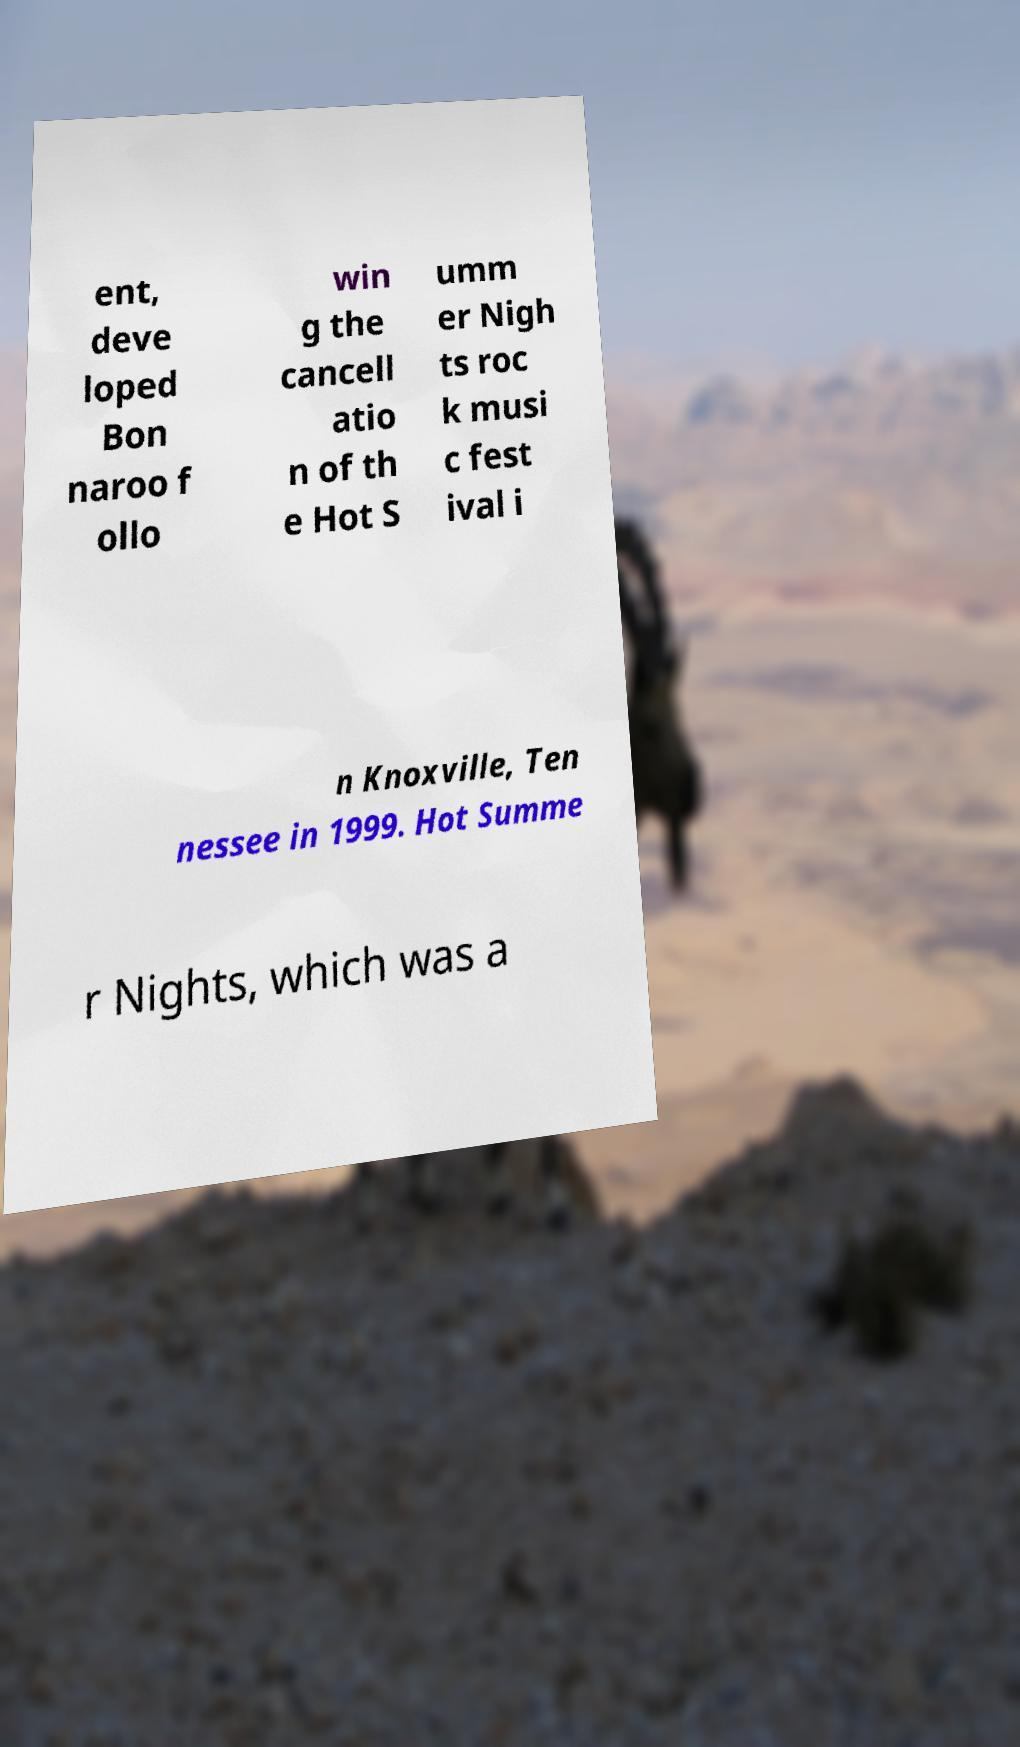Please read and relay the text visible in this image. What does it say? ent, deve loped Bon naroo f ollo win g the cancell atio n of th e Hot S umm er Nigh ts roc k musi c fest ival i n Knoxville, Ten nessee in 1999. Hot Summe r Nights, which was a 